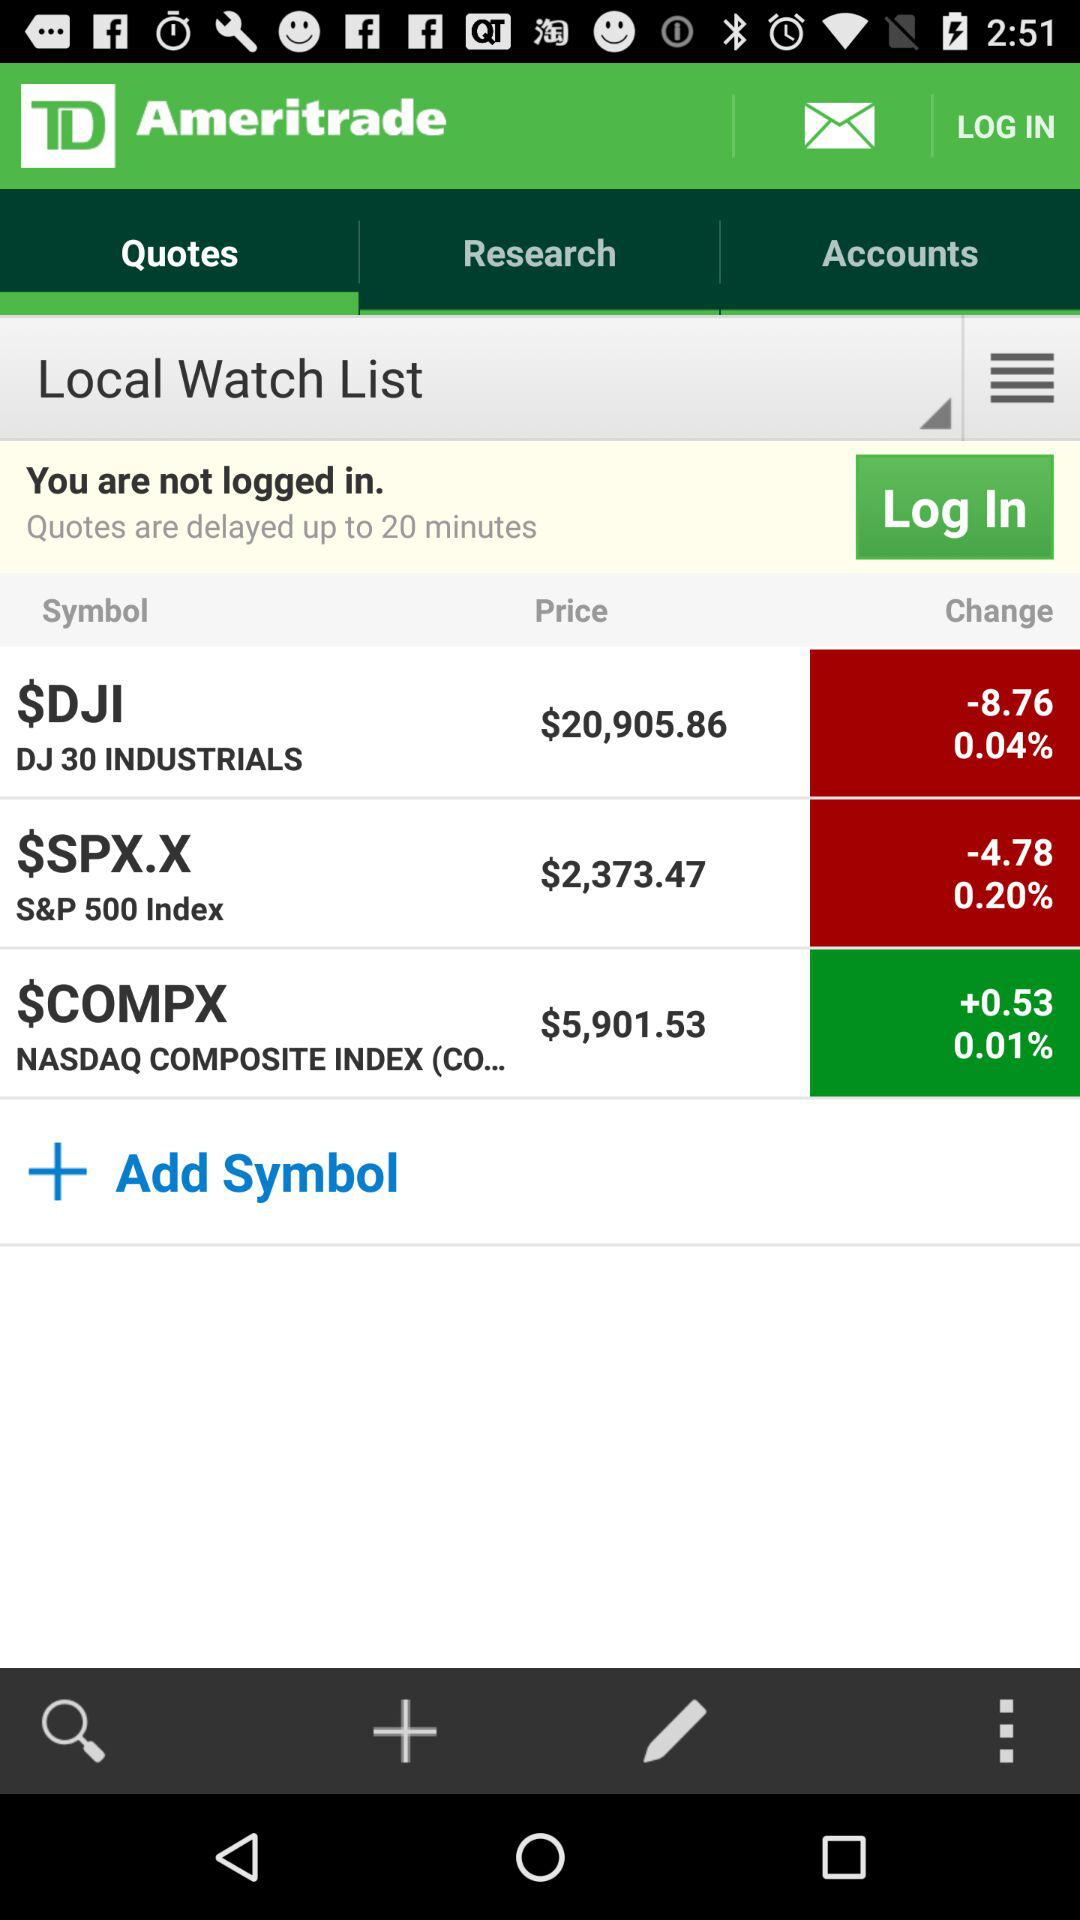What is the percentage drop in price for "DJ 30 INDUSTRIALS"? The drop in price for "DJ 30 INDUSTRIALS" is 0.04%. 